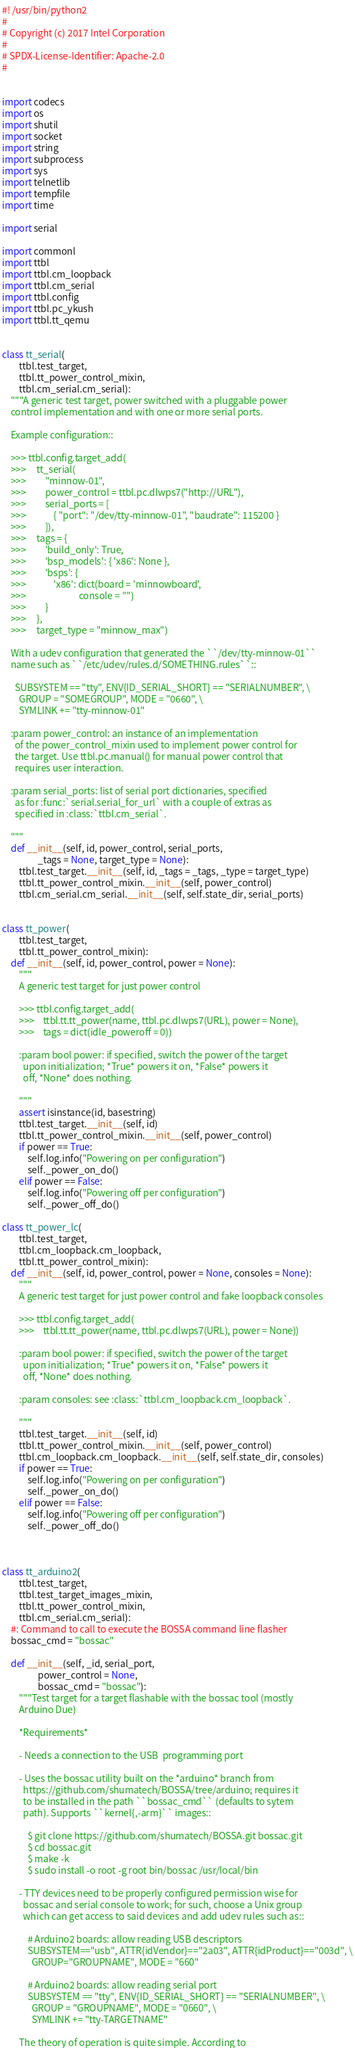Convert code to text. <code><loc_0><loc_0><loc_500><loc_500><_Python_>#! /usr/bin/python2
#
# Copyright (c) 2017 Intel Corporation
#
# SPDX-License-Identifier: Apache-2.0
#


import codecs
import os
import shutil
import socket
import string
import subprocess
import sys
import telnetlib
import tempfile
import time

import serial

import commonl
import ttbl
import ttbl.cm_loopback
import ttbl.cm_serial
import ttbl.config
import ttbl.pc_ykush
import ttbl.tt_qemu


class tt_serial(
        ttbl.test_target,
        ttbl.tt_power_control_mixin,
        ttbl.cm_serial.cm_serial):
    """A generic test target, power switched with a pluggable power
    control implementation and with one or more serial ports.

    Example configuration::

    >>> ttbl.config.target_add(
    >>>     tt_serial(
    >>>         "minnow-01",
    >>>         power_control = ttbl.pc.dlwps7("http://URL"),
    >>>         serial_ports = [
    >>>             { "port": "/dev/tty-minnow-01", "baudrate": 115200 }
    >>>         ]),
    >>>     tags = {
    >>>         'build_only': True,
    >>>         'bsp_models': { 'x86': None },
    >>>         'bsps': {
    >>>             'x86': dict(board = 'minnowboard',
    >>>                         console = "")
    >>>         }
    >>>     },
    >>>     target_type = "minnow_max")

    With a udev configuration that generated the ``/dev/tty-minnow-01``
    name such as ``/etc/udev/rules.d/SOMETHING.rules``::

      SUBSYSTEM == "tty", ENV{ID_SERIAL_SHORT} == "SERIALNUMBER", \
        GROUP = "SOMEGROUP", MODE = "0660", \
        SYMLINK += "tty-minnow-01"

    :param power_control: an instance of an implementation
      of the power_control_mixin used to implement power control for
      the target. Use ttbl.pc.manual() for manual power control that
      requires user interaction.

    :param serial_ports: list of serial port dictionaries, specified
      as for :func:`serial.serial_for_url` with a couple of extras as
      specified in :class:`ttbl.cm_serial`.

    """
    def __init__(self, id, power_control, serial_ports,
                 _tags = None, target_type = None):
        ttbl.test_target.__init__(self, id, _tags = _tags, _type = target_type)
        ttbl.tt_power_control_mixin.__init__(self, power_control)
        ttbl.cm_serial.cm_serial.__init__(self, self.state_dir, serial_ports)


class tt_power(
        ttbl.test_target,
        ttbl.tt_power_control_mixin):
    def __init__(self, id, power_control, power = None):
        """
        A generic test target for just power control

        >>> ttbl.config.target_add(
        >>>    ttbl.tt.tt_power(name, ttbl.pc.dlwps7(URL), power = None),
        >>>    tags = dict(idle_poweroff = 0))

        :param bool power: if specified, switch the power of the target
          upon initialization; *True* powers it on, *False* powers it
          off, *None* does nothing.

        """
        assert isinstance(id, basestring)
        ttbl.test_target.__init__(self, id)
        ttbl.tt_power_control_mixin.__init__(self, power_control)
        if power == True:
            self.log.info("Powering on per configuration")
            self._power_on_do()
        elif power == False:
            self.log.info("Powering off per configuration")
            self._power_off_do()

class tt_power_lc(
        ttbl.test_target,
        ttbl.cm_loopback.cm_loopback,
        ttbl.tt_power_control_mixin):
    def __init__(self, id, power_control, power = None, consoles = None):
        """
        A generic test target for just power control and fake loopback consoles

        >>> ttbl.config.target_add(
        >>>    ttbl.tt.tt_power(name, ttbl.pc.dlwps7(URL), power = None))

        :param bool power: if specified, switch the power of the target
          upon initialization; *True* powers it on, *False* powers it
          off, *None* does nothing.

        :param consoles: see :class:`ttbl.cm_loopback.cm_loopback`.

        """
        ttbl.test_target.__init__(self, id)
        ttbl.tt_power_control_mixin.__init__(self, power_control)
        ttbl.cm_loopback.cm_loopback.__init__(self, self.state_dir, consoles)
        if power == True:
            self.log.info("Powering on per configuration")
            self._power_on_do()
        elif power == False:
            self.log.info("Powering off per configuration")
            self._power_off_do()



class tt_arduino2(
        ttbl.test_target,
        ttbl.test_target_images_mixin,
        ttbl.tt_power_control_mixin,
        ttbl.cm_serial.cm_serial):
    #: Command to call to execute the BOSSA command line flasher
    bossac_cmd = "bossac"

    def __init__(self, _id, serial_port,
                 power_control = None,
                 bossac_cmd = "bossac"):
        """Test target for a target flashable with the bossac tool (mostly
        Arduino Due)

        *Requirements*

        - Needs a connection to the USB  programming port

        - Uses the bossac utility built on the *arduino* branch from
          https://github.com/shumatech/BOSSA/tree/arduino; requires it
          to be installed in the path ``bossac_cmd`` (defaults to sytem
          path). Supports ``kernel{,-arm}`` images::

            $ git clone https://github.com/shumatech/BOSSA.git bossac.git
            $ cd bossac.git
            $ make -k
            $ sudo install -o root -g root bin/bossac /usr/local/bin

        - TTY devices need to be properly configured permission wise for
          bossac and serial console to work; for such, choose a Unix group
          which can get access to said devices and add udev rules such as::

            # Arduino2 boards: allow reading USB descriptors
            SUBSYSTEM=="usb", ATTR{idVendor}=="2a03", ATTR{idProduct}=="003d", \
              GROUP="GROUPNAME", MODE = "660"

            # Arduino2 boards: allow reading serial port
            SUBSYSTEM == "tty", ENV{ID_SERIAL_SHORT} == "SERIALNUMBER", \
              GROUP = "GROUPNAME", MODE = "0660", \
              SYMLINK += "tty-TARGETNAME"

        The theory of operation is quite simple. According to</code> 